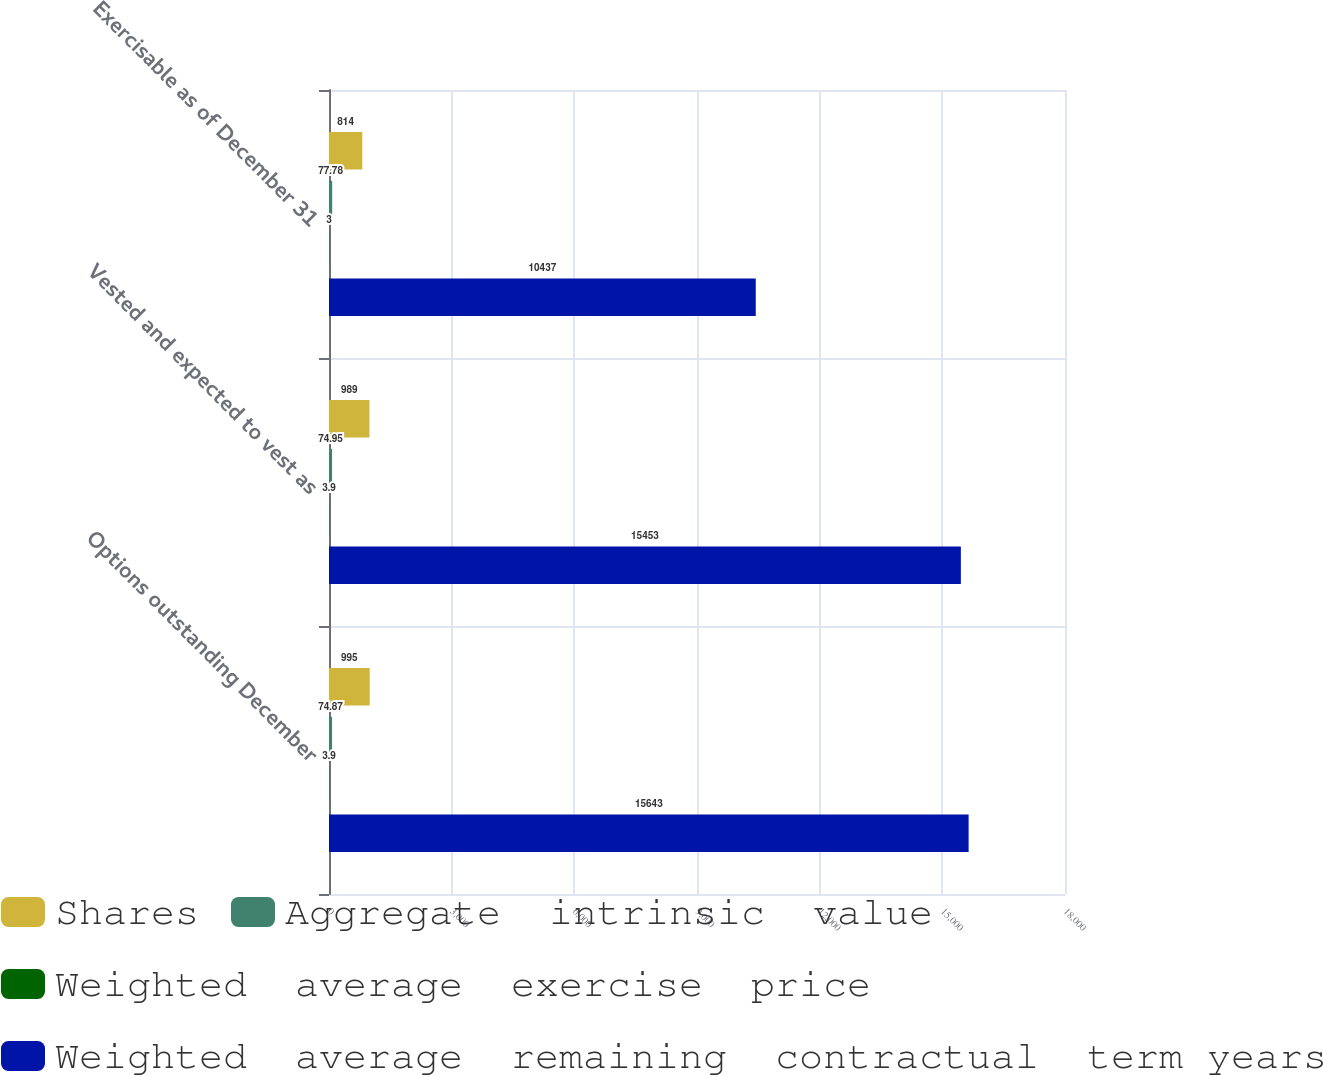Convert chart to OTSL. <chart><loc_0><loc_0><loc_500><loc_500><stacked_bar_chart><ecel><fcel>Options outstanding December<fcel>Vested and expected to vest as<fcel>Exercisable as of December 31<nl><fcel>Shares<fcel>995<fcel>989<fcel>814<nl><fcel>Aggregate  intrinsic  value<fcel>74.87<fcel>74.95<fcel>77.78<nl><fcel>Weighted  average  exercise  price<fcel>3.9<fcel>3.9<fcel>3<nl><fcel>Weighted  average  remaining  contractual  term years<fcel>15643<fcel>15453<fcel>10437<nl></chart> 